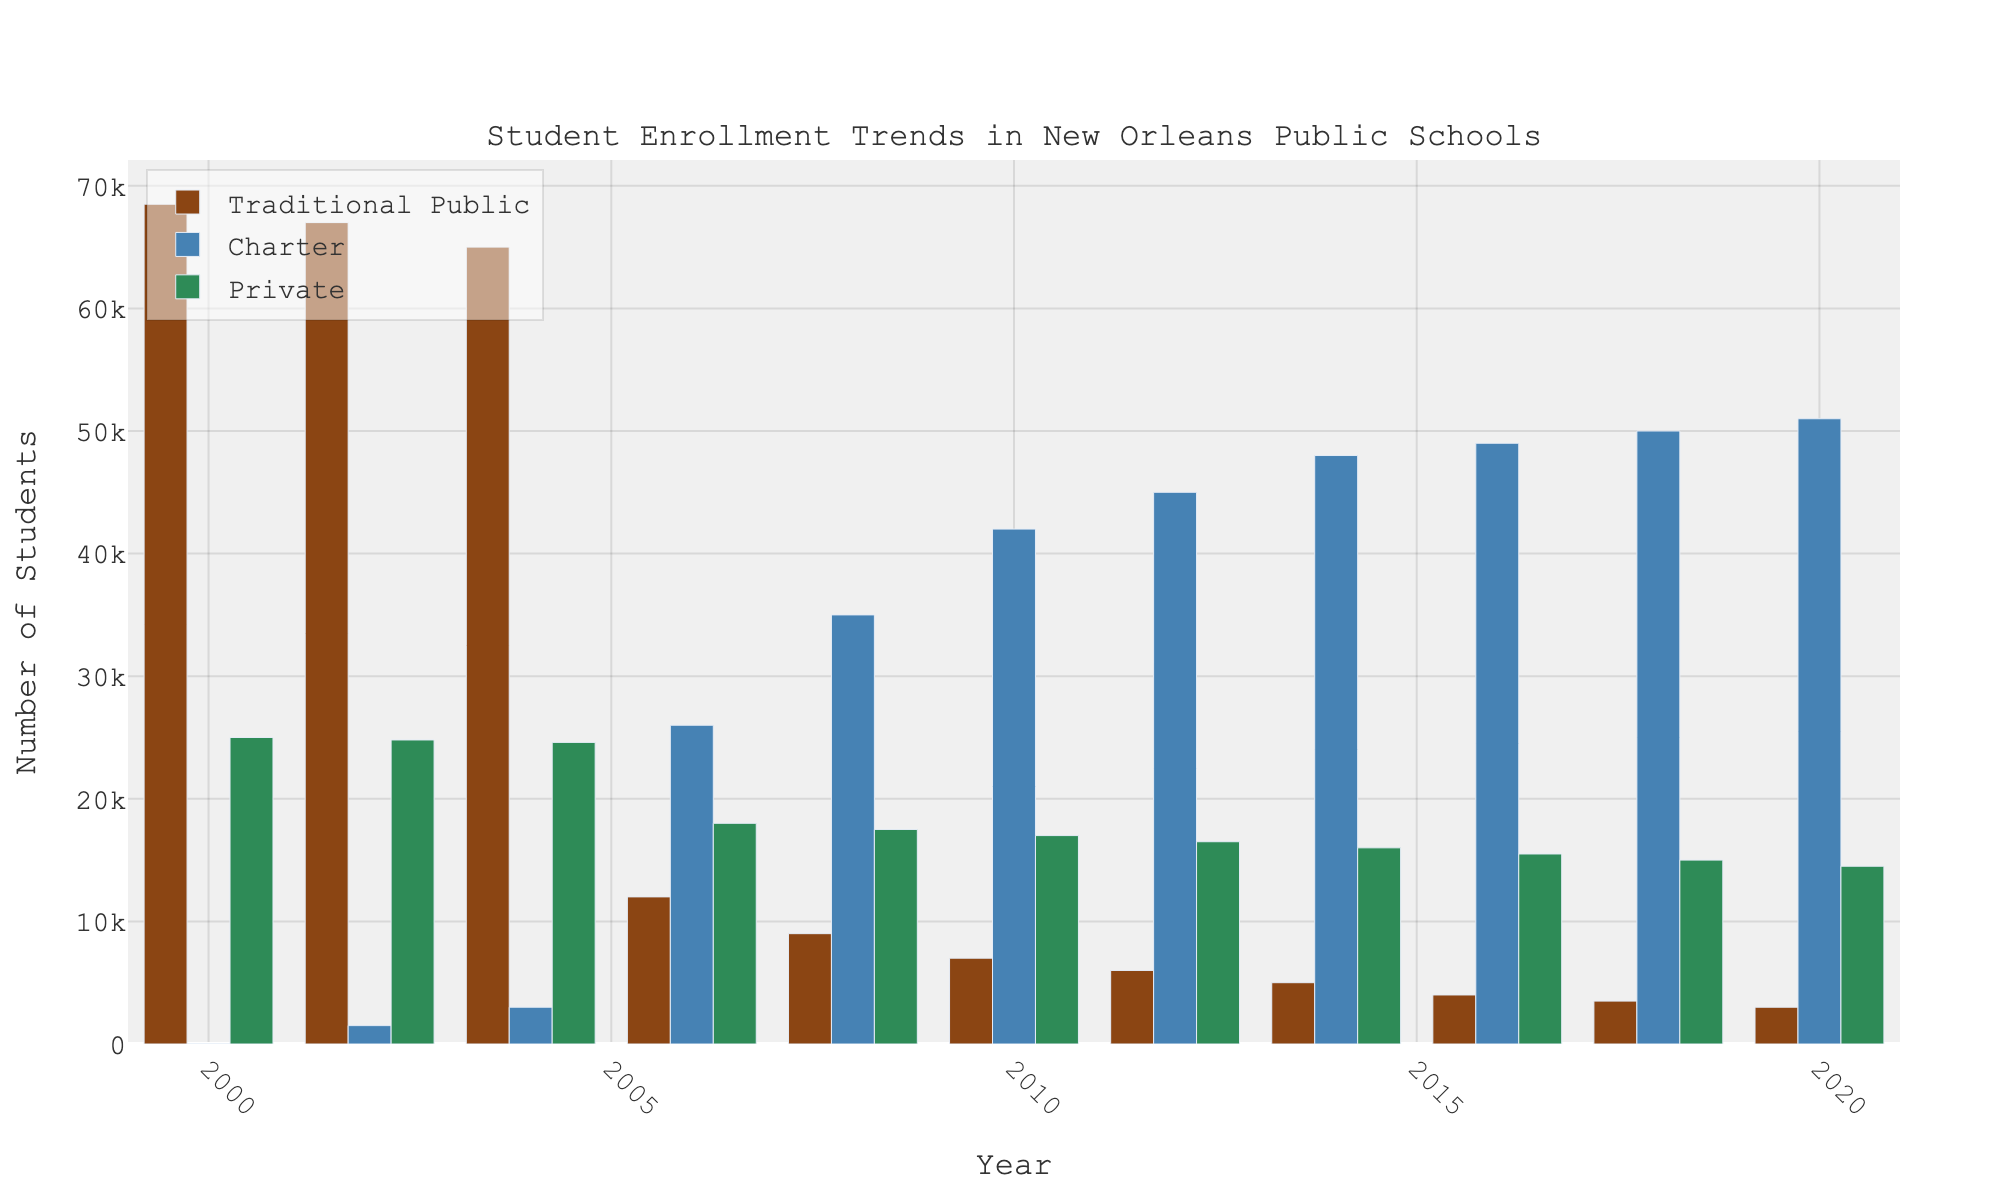What year did charter school enrollments surpass traditional public school enrollments? Examine the heights of the bars for traditional public and charter schools. In 2006, the bar for charter schools is higher than the bar for traditional public schools for the first time.
Answer: 2006 How did traditional public school enrollments change from 2000 to 2020? Check the height of the traditional public school bars in 2000 and 2020. They decrease from 68,500 in 2000 to 3,000 in 2020. Calculate the difference: 68,500 - 3,000 = 65,500 students.
Answer: Decreased by 65,500 Which type of school had the highest enrollment in 2018? Look at the heights of the bars in 2018. The charter school bar is the tallest compared to traditional public and private schools.
Answer: Charter How much did private school enrollments decrease by from 2000 to 2020? Compare the private school bars in 2000 and 2020. The decrease is 25,000 (2000) - 14,500 (2020) = 10,500 students.
Answer: 10,500 What is the total enrollment across all school types in 2010? Sum the heights of the bars for traditional public (7,000), charter (42,000), and private (17,000) schools in 2010: 7,000 + 42,000 + 17,000 = 66,000 students.
Answer: 66,000 Did private school enrollments ever exceed 25,000 students? Observe the height of the private school bars. The initial value in 2000 is exactly 25,000 but never exceeds it in any other years shown.
Answer: No Between 2006 and 2012, which type of school saw the largest growth in enrollment? Calculate the differences in enrollments from 2006 to 2012 for each type:
- Traditional Public: 6,000 (2012) - 12,000 (2006) = -6,000
- Charter: 45,000 (2012) - 26,000 (2006) = 19,000
- Private: 16,500 (2012) - 18,000 (2006) = -1,500
Charter schools had the largest growth by 19,000 students.
Answer: Charter How are the colors associated with each school type distributed visually? Describe the colors of the bars in the chart:
- Traditional Public: brown
- Charter: blue
- Private: green
Answer: Brown for Traditional Public, Blue for Charter, Green for Private 